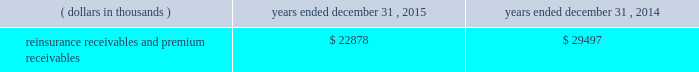Certain reclassifications and format changes have been made to prior years 2019 amounts to conform to the 2015 presentation .
Investments .
Fixed maturity and equity security investments available for sale , at market value , reflect unrealized appreciation and depreciation , as a result of temporary changes in market value during the period , in shareholders 2019 equity , net of income taxes in 201caccumulated other comprehensive income ( loss ) 201d in the consolidated balance sheets .
Fixed maturity and equity securities carried at fair value reflect fair value re- measurements as net realized capital gains and losses in the consolidated statements of operations and comprehensive income ( loss ) .
The company records changes in fair value for its fixed maturities available for sale , at market value through shareholders 2019 equity , net of taxes in accumulated other comprehensive income ( loss ) since cash flows from these investments will be primarily used to settle its reserve for losses and loss adjustment expense liabilities .
The company anticipates holding these investments for an extended period as the cash flow from interest and maturities will fund the projected payout of these liabilities .
Fixed maturities carried at fair value represent a portfolio of convertible bond securities , which have characteristics similar to equity securities and at times , designated foreign denominated fixed maturity securities , which will be used to settle loss and loss adjustment reserves in the same currency .
The company carries all of its equity securities at fair value except for mutual fund investments whose underlying investments are comprised of fixed maturity securities .
For equity securities , available for sale , at fair value , the company reflects changes in value as net realized capital gains and losses since these securities may be sold in the near term depending on financial market conditions .
Interest income on all fixed maturities and dividend income on all equity securities are included as part of net investment income in the consolidated statements of operations and comprehensive income ( loss ) .
Unrealized losses on fixed maturities , which are deemed other-than-temporary and related to the credit quality of a security , are charged to net income ( loss ) as net realized capital losses .
Short-term investments are stated at cost , which approximates market value .
Realized gains or losses on sales of investments are determined on the basis of identified cost .
For non- publicly traded securities , market prices are determined through the use of pricing models that evaluate securities relative to the u.s .
Treasury yield curve , taking into account the issue type , credit quality , and cash flow characteristics of each security .
For publicly traded securities , market value is based on quoted market prices or valuation models that use observable market inputs .
When a sector of the financial markets is inactive or illiquid , the company may use its own assumptions about future cash flows and risk-adjusted discount rates to determine fair value .
Retrospective adjustments are employed to recalculate the values of asset-backed securities .
Each acquisition lot is reviewed to recalculate the effective yield .
The recalculated effective yield is used to derive a book value as if the new yield were applied at the time of acquisition .
Outstanding principal factors from the time of acquisition to the adjustment date are used to calculate the prepayment history for all applicable securities .
Conditional prepayment rates , computed with life to date factor histories and weighted average maturities , are used to effect the calculation of projected and prepayments for pass-through security types .
Other invested assets include limited partnerships and rabbi trusts .
Limited partnerships are accounted for under the equity method of accounting , which can be recorded on a monthly or quarterly lag .
Uncollectible receivable balances .
The company provides reserves for uncollectible reinsurance recoverable and premium receivable balances based on management 2019s assessment of the collectability of the outstanding balances .
Such reserves are presented in the table below for the periods indicated. .

What is the ratio of the reinsurance receivables and premium receivables for 2015 to 2014? 
Computations: (22878 / 29497)
Answer: 0.7756. 